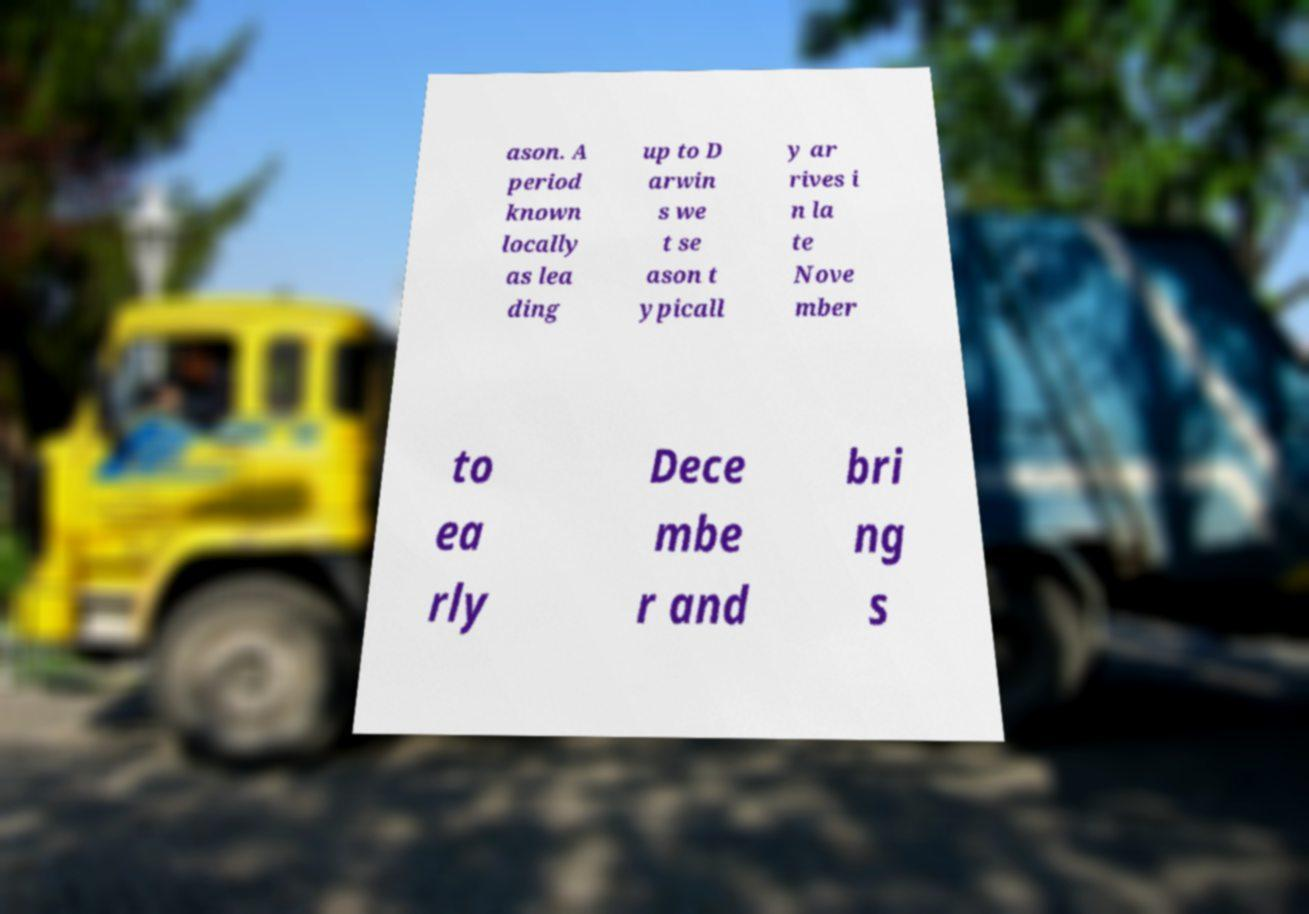There's text embedded in this image that I need extracted. Can you transcribe it verbatim? ason. A period known locally as lea ding up to D arwin s we t se ason t ypicall y ar rives i n la te Nove mber to ea rly Dece mbe r and bri ng s 